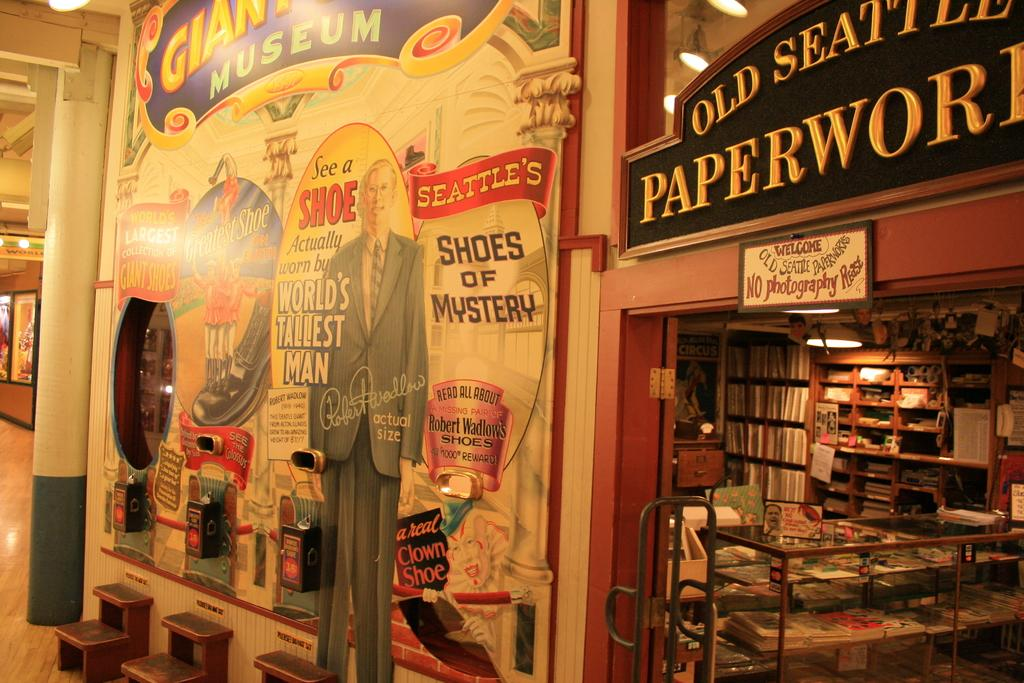<image>
Summarize the visual content of the image. A book store has stacks of books on shelves and is located in Seattle. 